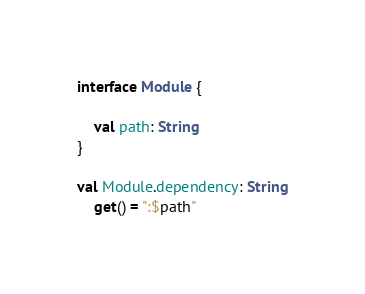Convert code to text. <code><loc_0><loc_0><loc_500><loc_500><_Kotlin_>interface Module {

    val path: String
}

val Module.dependency: String
    get() = ":$path"</code> 